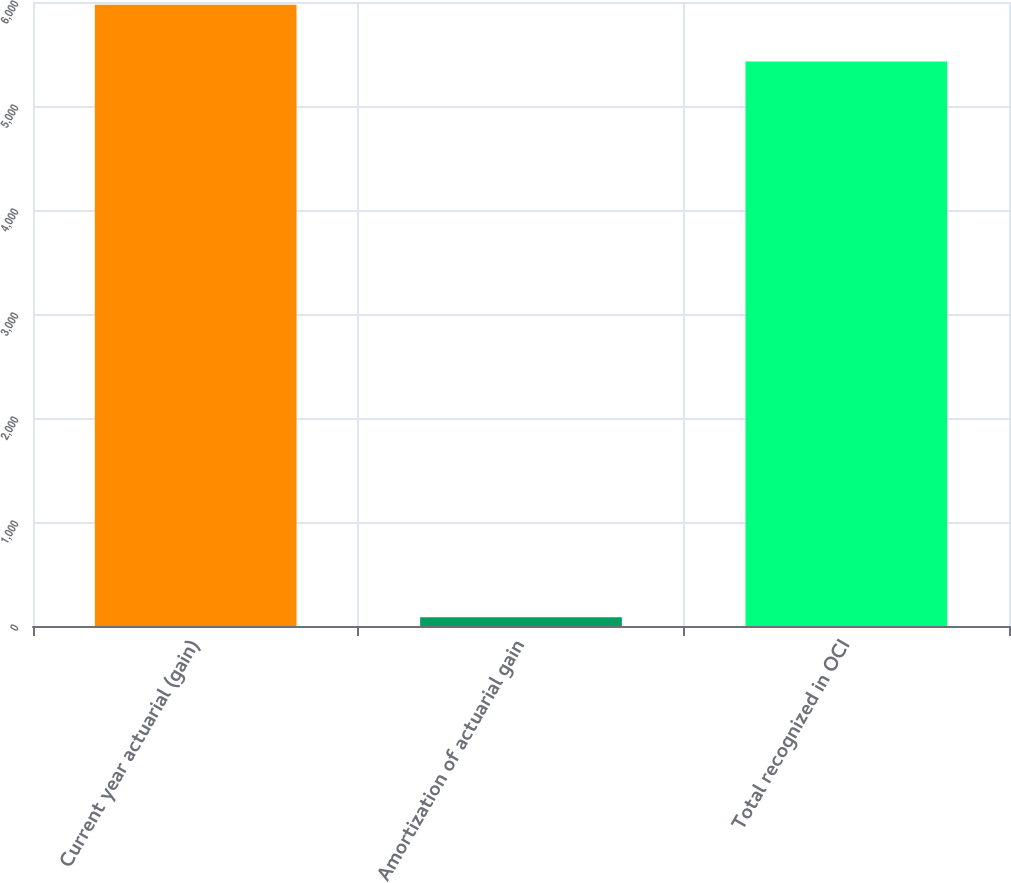Convert chart to OTSL. <chart><loc_0><loc_0><loc_500><loc_500><bar_chart><fcel>Current year actuarial (gain)<fcel>Amortization of actuarial gain<fcel>Total recognized in OCI<nl><fcel>5973.6<fcel>83<fcel>5428<nl></chart> 